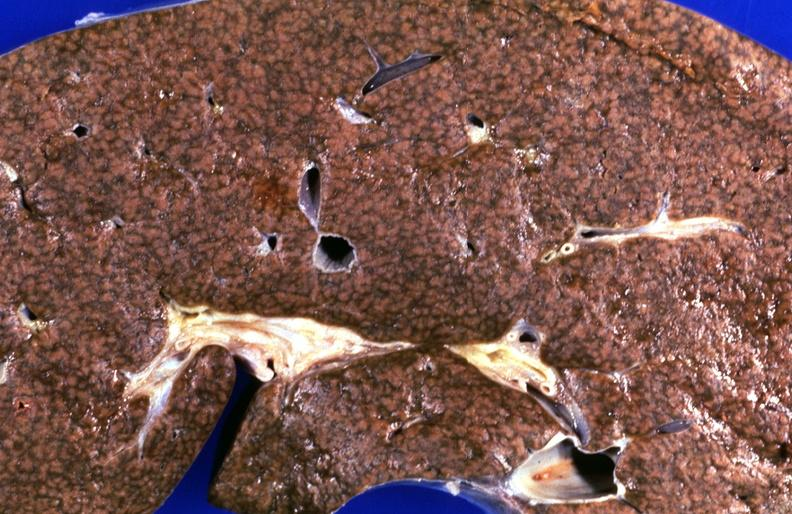what does this image show?
Answer the question using a single word or phrase. Kidney 